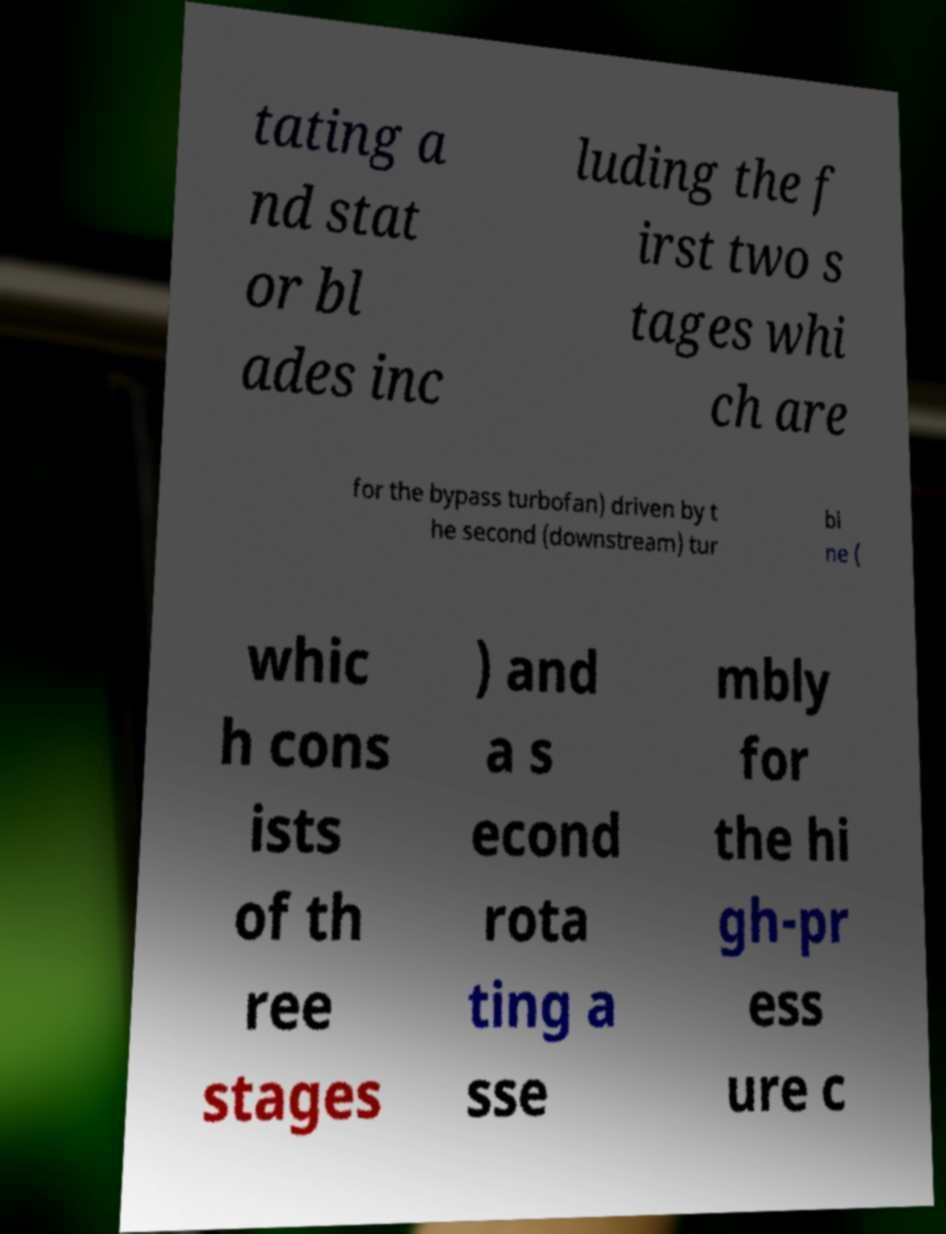Can you accurately transcribe the text from the provided image for me? tating a nd stat or bl ades inc luding the f irst two s tages whi ch are for the bypass turbofan) driven by t he second (downstream) tur bi ne ( whic h cons ists of th ree stages ) and a s econd rota ting a sse mbly for the hi gh-pr ess ure c 